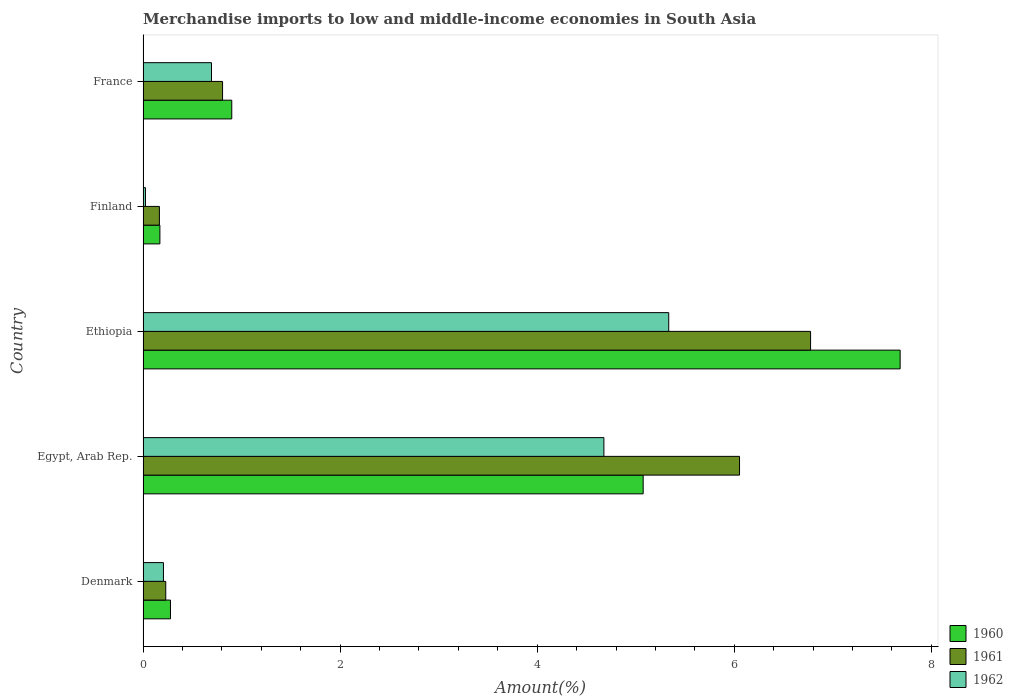How many different coloured bars are there?
Your response must be concise. 3. How many groups of bars are there?
Give a very brief answer. 5. Are the number of bars on each tick of the Y-axis equal?
Your response must be concise. Yes. How many bars are there on the 1st tick from the top?
Make the answer very short. 3. How many bars are there on the 4th tick from the bottom?
Provide a succinct answer. 3. What is the percentage of amount earned from merchandise imports in 1960 in France?
Your answer should be compact. 0.9. Across all countries, what is the maximum percentage of amount earned from merchandise imports in 1961?
Provide a succinct answer. 6.77. Across all countries, what is the minimum percentage of amount earned from merchandise imports in 1961?
Your response must be concise. 0.17. In which country was the percentage of amount earned from merchandise imports in 1962 maximum?
Your answer should be very brief. Ethiopia. In which country was the percentage of amount earned from merchandise imports in 1960 minimum?
Give a very brief answer. Finland. What is the total percentage of amount earned from merchandise imports in 1960 in the graph?
Provide a succinct answer. 14.11. What is the difference between the percentage of amount earned from merchandise imports in 1961 in Denmark and that in Finland?
Your answer should be very brief. 0.06. What is the difference between the percentage of amount earned from merchandise imports in 1962 in Denmark and the percentage of amount earned from merchandise imports in 1961 in France?
Your answer should be compact. -0.6. What is the average percentage of amount earned from merchandise imports in 1960 per country?
Provide a short and direct response. 2.82. What is the difference between the percentage of amount earned from merchandise imports in 1961 and percentage of amount earned from merchandise imports in 1960 in France?
Provide a succinct answer. -0.09. In how many countries, is the percentage of amount earned from merchandise imports in 1962 greater than 7.2 %?
Your response must be concise. 0. What is the ratio of the percentage of amount earned from merchandise imports in 1960 in Ethiopia to that in France?
Provide a succinct answer. 8.54. Is the percentage of amount earned from merchandise imports in 1960 in Denmark less than that in Finland?
Your answer should be very brief. No. Is the difference between the percentage of amount earned from merchandise imports in 1961 in Denmark and Ethiopia greater than the difference between the percentage of amount earned from merchandise imports in 1960 in Denmark and Ethiopia?
Provide a succinct answer. Yes. What is the difference between the highest and the second highest percentage of amount earned from merchandise imports in 1960?
Offer a very short reply. 2.61. What is the difference between the highest and the lowest percentage of amount earned from merchandise imports in 1961?
Offer a very short reply. 6.61. Is the sum of the percentage of amount earned from merchandise imports in 1962 in Egypt, Arab Rep. and Ethiopia greater than the maximum percentage of amount earned from merchandise imports in 1961 across all countries?
Ensure brevity in your answer.  Yes. What does the 1st bar from the bottom in Finland represents?
Offer a terse response. 1960. Are all the bars in the graph horizontal?
Your answer should be compact. Yes. Are the values on the major ticks of X-axis written in scientific E-notation?
Offer a very short reply. No. Does the graph contain any zero values?
Provide a short and direct response. No. Does the graph contain grids?
Give a very brief answer. No. How many legend labels are there?
Your answer should be very brief. 3. How are the legend labels stacked?
Your answer should be compact. Vertical. What is the title of the graph?
Your answer should be very brief. Merchandise imports to low and middle-income economies in South Asia. Does "1987" appear as one of the legend labels in the graph?
Keep it short and to the point. No. What is the label or title of the X-axis?
Provide a succinct answer. Amount(%). What is the label or title of the Y-axis?
Provide a succinct answer. Country. What is the Amount(%) of 1960 in Denmark?
Provide a succinct answer. 0.28. What is the Amount(%) of 1961 in Denmark?
Make the answer very short. 0.23. What is the Amount(%) in 1962 in Denmark?
Give a very brief answer. 0.21. What is the Amount(%) in 1960 in Egypt, Arab Rep.?
Ensure brevity in your answer.  5.08. What is the Amount(%) of 1961 in Egypt, Arab Rep.?
Your answer should be very brief. 6.05. What is the Amount(%) of 1962 in Egypt, Arab Rep.?
Your answer should be compact. 4.68. What is the Amount(%) of 1960 in Ethiopia?
Ensure brevity in your answer.  7.68. What is the Amount(%) of 1961 in Ethiopia?
Offer a terse response. 6.77. What is the Amount(%) of 1962 in Ethiopia?
Make the answer very short. 5.33. What is the Amount(%) of 1960 in Finland?
Provide a short and direct response. 0.17. What is the Amount(%) of 1961 in Finland?
Provide a short and direct response. 0.17. What is the Amount(%) of 1962 in Finland?
Your answer should be compact. 0.02. What is the Amount(%) in 1960 in France?
Your answer should be very brief. 0.9. What is the Amount(%) in 1961 in France?
Give a very brief answer. 0.81. What is the Amount(%) in 1962 in France?
Provide a short and direct response. 0.69. Across all countries, what is the maximum Amount(%) in 1960?
Provide a succinct answer. 7.68. Across all countries, what is the maximum Amount(%) of 1961?
Provide a short and direct response. 6.77. Across all countries, what is the maximum Amount(%) of 1962?
Your response must be concise. 5.33. Across all countries, what is the minimum Amount(%) in 1960?
Your response must be concise. 0.17. Across all countries, what is the minimum Amount(%) of 1961?
Offer a terse response. 0.17. Across all countries, what is the minimum Amount(%) of 1962?
Offer a very short reply. 0.02. What is the total Amount(%) of 1960 in the graph?
Offer a very short reply. 14.11. What is the total Amount(%) of 1961 in the graph?
Give a very brief answer. 14.03. What is the total Amount(%) in 1962 in the graph?
Your answer should be very brief. 10.94. What is the difference between the Amount(%) of 1960 in Denmark and that in Egypt, Arab Rep.?
Your response must be concise. -4.8. What is the difference between the Amount(%) in 1961 in Denmark and that in Egypt, Arab Rep.?
Keep it short and to the point. -5.82. What is the difference between the Amount(%) of 1962 in Denmark and that in Egypt, Arab Rep.?
Offer a very short reply. -4.47. What is the difference between the Amount(%) of 1960 in Denmark and that in Ethiopia?
Your answer should be very brief. -7.4. What is the difference between the Amount(%) of 1961 in Denmark and that in Ethiopia?
Provide a succinct answer. -6.54. What is the difference between the Amount(%) in 1962 in Denmark and that in Ethiopia?
Your response must be concise. -5.13. What is the difference between the Amount(%) in 1960 in Denmark and that in Finland?
Your answer should be very brief. 0.11. What is the difference between the Amount(%) of 1961 in Denmark and that in Finland?
Offer a terse response. 0.06. What is the difference between the Amount(%) in 1962 in Denmark and that in Finland?
Offer a terse response. 0.18. What is the difference between the Amount(%) in 1960 in Denmark and that in France?
Offer a very short reply. -0.62. What is the difference between the Amount(%) of 1961 in Denmark and that in France?
Ensure brevity in your answer.  -0.58. What is the difference between the Amount(%) in 1962 in Denmark and that in France?
Your answer should be compact. -0.49. What is the difference between the Amount(%) in 1960 in Egypt, Arab Rep. and that in Ethiopia?
Offer a terse response. -2.61. What is the difference between the Amount(%) in 1961 in Egypt, Arab Rep. and that in Ethiopia?
Give a very brief answer. -0.72. What is the difference between the Amount(%) in 1962 in Egypt, Arab Rep. and that in Ethiopia?
Provide a short and direct response. -0.66. What is the difference between the Amount(%) of 1960 in Egypt, Arab Rep. and that in Finland?
Ensure brevity in your answer.  4.9. What is the difference between the Amount(%) of 1961 in Egypt, Arab Rep. and that in Finland?
Make the answer very short. 5.89. What is the difference between the Amount(%) of 1962 in Egypt, Arab Rep. and that in Finland?
Provide a short and direct response. 4.65. What is the difference between the Amount(%) of 1960 in Egypt, Arab Rep. and that in France?
Ensure brevity in your answer.  4.18. What is the difference between the Amount(%) of 1961 in Egypt, Arab Rep. and that in France?
Offer a very short reply. 5.25. What is the difference between the Amount(%) of 1962 in Egypt, Arab Rep. and that in France?
Ensure brevity in your answer.  3.98. What is the difference between the Amount(%) of 1960 in Ethiopia and that in Finland?
Provide a succinct answer. 7.51. What is the difference between the Amount(%) of 1961 in Ethiopia and that in Finland?
Your answer should be very brief. 6.61. What is the difference between the Amount(%) in 1962 in Ethiopia and that in Finland?
Offer a very short reply. 5.31. What is the difference between the Amount(%) in 1960 in Ethiopia and that in France?
Your response must be concise. 6.78. What is the difference between the Amount(%) of 1961 in Ethiopia and that in France?
Give a very brief answer. 5.97. What is the difference between the Amount(%) in 1962 in Ethiopia and that in France?
Your answer should be compact. 4.64. What is the difference between the Amount(%) of 1960 in Finland and that in France?
Offer a terse response. -0.73. What is the difference between the Amount(%) in 1961 in Finland and that in France?
Provide a succinct answer. -0.64. What is the difference between the Amount(%) in 1962 in Finland and that in France?
Your answer should be very brief. -0.67. What is the difference between the Amount(%) of 1960 in Denmark and the Amount(%) of 1961 in Egypt, Arab Rep.?
Your answer should be compact. -5.78. What is the difference between the Amount(%) in 1960 in Denmark and the Amount(%) in 1962 in Egypt, Arab Rep.?
Give a very brief answer. -4.4. What is the difference between the Amount(%) of 1961 in Denmark and the Amount(%) of 1962 in Egypt, Arab Rep.?
Provide a short and direct response. -4.45. What is the difference between the Amount(%) in 1960 in Denmark and the Amount(%) in 1961 in Ethiopia?
Give a very brief answer. -6.5. What is the difference between the Amount(%) in 1960 in Denmark and the Amount(%) in 1962 in Ethiopia?
Make the answer very short. -5.06. What is the difference between the Amount(%) of 1961 in Denmark and the Amount(%) of 1962 in Ethiopia?
Keep it short and to the point. -5.1. What is the difference between the Amount(%) in 1960 in Denmark and the Amount(%) in 1961 in Finland?
Provide a succinct answer. 0.11. What is the difference between the Amount(%) in 1960 in Denmark and the Amount(%) in 1962 in Finland?
Your response must be concise. 0.25. What is the difference between the Amount(%) in 1961 in Denmark and the Amount(%) in 1962 in Finland?
Make the answer very short. 0.21. What is the difference between the Amount(%) of 1960 in Denmark and the Amount(%) of 1961 in France?
Provide a succinct answer. -0.53. What is the difference between the Amount(%) of 1960 in Denmark and the Amount(%) of 1962 in France?
Your response must be concise. -0.42. What is the difference between the Amount(%) of 1961 in Denmark and the Amount(%) of 1962 in France?
Offer a terse response. -0.46. What is the difference between the Amount(%) in 1960 in Egypt, Arab Rep. and the Amount(%) in 1961 in Ethiopia?
Offer a terse response. -1.7. What is the difference between the Amount(%) of 1960 in Egypt, Arab Rep. and the Amount(%) of 1962 in Ethiopia?
Make the answer very short. -0.26. What is the difference between the Amount(%) in 1961 in Egypt, Arab Rep. and the Amount(%) in 1962 in Ethiopia?
Your answer should be compact. 0.72. What is the difference between the Amount(%) of 1960 in Egypt, Arab Rep. and the Amount(%) of 1961 in Finland?
Keep it short and to the point. 4.91. What is the difference between the Amount(%) in 1960 in Egypt, Arab Rep. and the Amount(%) in 1962 in Finland?
Keep it short and to the point. 5.05. What is the difference between the Amount(%) of 1961 in Egypt, Arab Rep. and the Amount(%) of 1962 in Finland?
Offer a terse response. 6.03. What is the difference between the Amount(%) in 1960 in Egypt, Arab Rep. and the Amount(%) in 1961 in France?
Make the answer very short. 4.27. What is the difference between the Amount(%) in 1960 in Egypt, Arab Rep. and the Amount(%) in 1962 in France?
Your response must be concise. 4.38. What is the difference between the Amount(%) in 1961 in Egypt, Arab Rep. and the Amount(%) in 1962 in France?
Offer a terse response. 5.36. What is the difference between the Amount(%) of 1960 in Ethiopia and the Amount(%) of 1961 in Finland?
Provide a succinct answer. 7.52. What is the difference between the Amount(%) of 1960 in Ethiopia and the Amount(%) of 1962 in Finland?
Your answer should be compact. 7.66. What is the difference between the Amount(%) in 1961 in Ethiopia and the Amount(%) in 1962 in Finland?
Offer a terse response. 6.75. What is the difference between the Amount(%) in 1960 in Ethiopia and the Amount(%) in 1961 in France?
Make the answer very short. 6.88. What is the difference between the Amount(%) of 1960 in Ethiopia and the Amount(%) of 1962 in France?
Your response must be concise. 6.99. What is the difference between the Amount(%) of 1961 in Ethiopia and the Amount(%) of 1962 in France?
Make the answer very short. 6.08. What is the difference between the Amount(%) in 1960 in Finland and the Amount(%) in 1961 in France?
Ensure brevity in your answer.  -0.64. What is the difference between the Amount(%) of 1960 in Finland and the Amount(%) of 1962 in France?
Offer a very short reply. -0.52. What is the difference between the Amount(%) of 1961 in Finland and the Amount(%) of 1962 in France?
Offer a very short reply. -0.53. What is the average Amount(%) in 1960 per country?
Give a very brief answer. 2.82. What is the average Amount(%) in 1961 per country?
Offer a terse response. 2.81. What is the average Amount(%) of 1962 per country?
Ensure brevity in your answer.  2.19. What is the difference between the Amount(%) in 1960 and Amount(%) in 1961 in Denmark?
Provide a succinct answer. 0.05. What is the difference between the Amount(%) in 1960 and Amount(%) in 1962 in Denmark?
Keep it short and to the point. 0.07. What is the difference between the Amount(%) in 1961 and Amount(%) in 1962 in Denmark?
Provide a short and direct response. 0.02. What is the difference between the Amount(%) of 1960 and Amount(%) of 1961 in Egypt, Arab Rep.?
Give a very brief answer. -0.98. What is the difference between the Amount(%) in 1960 and Amount(%) in 1962 in Egypt, Arab Rep.?
Offer a very short reply. 0.4. What is the difference between the Amount(%) of 1961 and Amount(%) of 1962 in Egypt, Arab Rep.?
Your answer should be very brief. 1.38. What is the difference between the Amount(%) of 1960 and Amount(%) of 1961 in Ethiopia?
Provide a short and direct response. 0.91. What is the difference between the Amount(%) in 1960 and Amount(%) in 1962 in Ethiopia?
Ensure brevity in your answer.  2.35. What is the difference between the Amount(%) of 1961 and Amount(%) of 1962 in Ethiopia?
Give a very brief answer. 1.44. What is the difference between the Amount(%) of 1960 and Amount(%) of 1961 in Finland?
Keep it short and to the point. 0.01. What is the difference between the Amount(%) in 1960 and Amount(%) in 1962 in Finland?
Your answer should be very brief. 0.15. What is the difference between the Amount(%) of 1961 and Amount(%) of 1962 in Finland?
Give a very brief answer. 0.14. What is the difference between the Amount(%) of 1960 and Amount(%) of 1961 in France?
Offer a terse response. 0.09. What is the difference between the Amount(%) in 1960 and Amount(%) in 1962 in France?
Offer a terse response. 0.21. What is the difference between the Amount(%) of 1961 and Amount(%) of 1962 in France?
Offer a terse response. 0.11. What is the ratio of the Amount(%) in 1960 in Denmark to that in Egypt, Arab Rep.?
Give a very brief answer. 0.05. What is the ratio of the Amount(%) in 1961 in Denmark to that in Egypt, Arab Rep.?
Ensure brevity in your answer.  0.04. What is the ratio of the Amount(%) of 1962 in Denmark to that in Egypt, Arab Rep.?
Ensure brevity in your answer.  0.04. What is the ratio of the Amount(%) in 1960 in Denmark to that in Ethiopia?
Provide a succinct answer. 0.04. What is the ratio of the Amount(%) of 1961 in Denmark to that in Ethiopia?
Make the answer very short. 0.03. What is the ratio of the Amount(%) in 1962 in Denmark to that in Ethiopia?
Provide a succinct answer. 0.04. What is the ratio of the Amount(%) in 1960 in Denmark to that in Finland?
Provide a succinct answer. 1.63. What is the ratio of the Amount(%) in 1961 in Denmark to that in Finland?
Ensure brevity in your answer.  1.39. What is the ratio of the Amount(%) in 1962 in Denmark to that in Finland?
Make the answer very short. 8.47. What is the ratio of the Amount(%) of 1960 in Denmark to that in France?
Offer a terse response. 0.31. What is the ratio of the Amount(%) of 1961 in Denmark to that in France?
Your answer should be compact. 0.29. What is the ratio of the Amount(%) in 1962 in Denmark to that in France?
Offer a terse response. 0.3. What is the ratio of the Amount(%) of 1960 in Egypt, Arab Rep. to that in Ethiopia?
Provide a succinct answer. 0.66. What is the ratio of the Amount(%) of 1961 in Egypt, Arab Rep. to that in Ethiopia?
Your response must be concise. 0.89. What is the ratio of the Amount(%) in 1962 in Egypt, Arab Rep. to that in Ethiopia?
Your answer should be very brief. 0.88. What is the ratio of the Amount(%) in 1960 in Egypt, Arab Rep. to that in Finland?
Give a very brief answer. 29.72. What is the ratio of the Amount(%) of 1961 in Egypt, Arab Rep. to that in Finland?
Your response must be concise. 36.5. What is the ratio of the Amount(%) of 1962 in Egypt, Arab Rep. to that in Finland?
Provide a succinct answer. 191.4. What is the ratio of the Amount(%) of 1960 in Egypt, Arab Rep. to that in France?
Offer a terse response. 5.64. What is the ratio of the Amount(%) of 1961 in Egypt, Arab Rep. to that in France?
Offer a very short reply. 7.5. What is the ratio of the Amount(%) in 1962 in Egypt, Arab Rep. to that in France?
Provide a short and direct response. 6.74. What is the ratio of the Amount(%) of 1960 in Ethiopia to that in Finland?
Make the answer very short. 44.98. What is the ratio of the Amount(%) of 1961 in Ethiopia to that in Finland?
Ensure brevity in your answer.  40.85. What is the ratio of the Amount(%) of 1962 in Ethiopia to that in Finland?
Keep it short and to the point. 218.33. What is the ratio of the Amount(%) in 1960 in Ethiopia to that in France?
Your answer should be compact. 8.54. What is the ratio of the Amount(%) of 1961 in Ethiopia to that in France?
Your answer should be compact. 8.4. What is the ratio of the Amount(%) of 1962 in Ethiopia to that in France?
Ensure brevity in your answer.  7.68. What is the ratio of the Amount(%) in 1960 in Finland to that in France?
Offer a very short reply. 0.19. What is the ratio of the Amount(%) in 1961 in Finland to that in France?
Your answer should be compact. 0.21. What is the ratio of the Amount(%) of 1962 in Finland to that in France?
Provide a short and direct response. 0.04. What is the difference between the highest and the second highest Amount(%) in 1960?
Your response must be concise. 2.61. What is the difference between the highest and the second highest Amount(%) in 1961?
Provide a short and direct response. 0.72. What is the difference between the highest and the second highest Amount(%) in 1962?
Keep it short and to the point. 0.66. What is the difference between the highest and the lowest Amount(%) in 1960?
Offer a very short reply. 7.51. What is the difference between the highest and the lowest Amount(%) of 1961?
Give a very brief answer. 6.61. What is the difference between the highest and the lowest Amount(%) of 1962?
Offer a terse response. 5.31. 